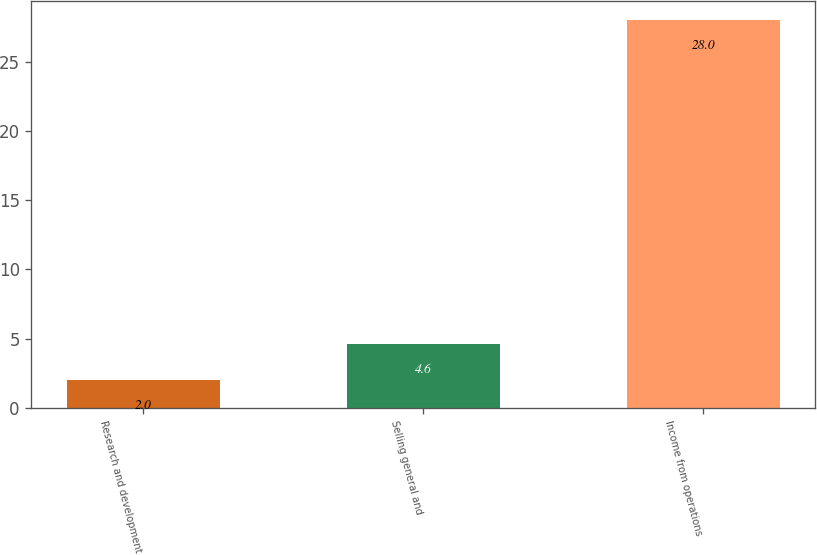Convert chart. <chart><loc_0><loc_0><loc_500><loc_500><bar_chart><fcel>Research and development<fcel>Selling general and<fcel>Income from operations<nl><fcel>2<fcel>4.6<fcel>28<nl></chart> 